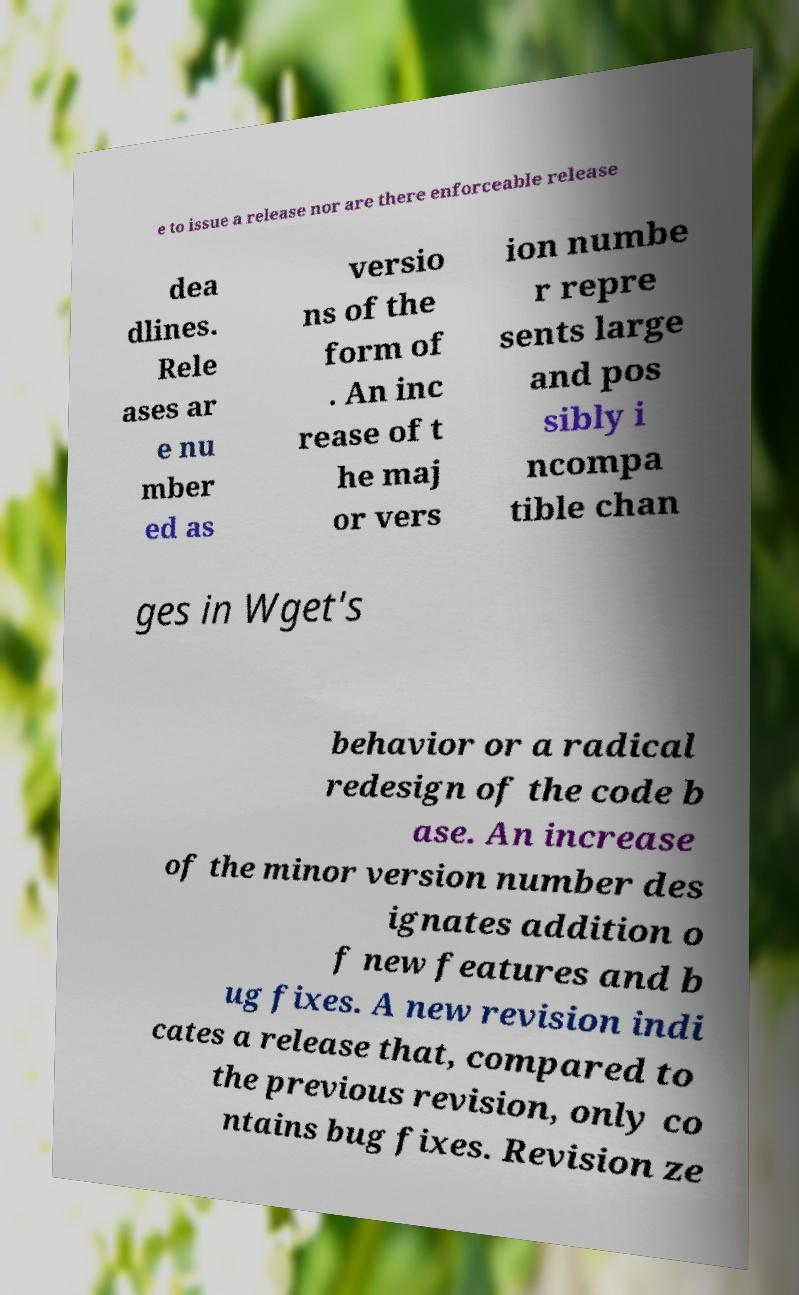I need the written content from this picture converted into text. Can you do that? e to issue a release nor are there enforceable release dea dlines. Rele ases ar e nu mber ed as versio ns of the form of . An inc rease of t he maj or vers ion numbe r repre sents large and pos sibly i ncompa tible chan ges in Wget's behavior or a radical redesign of the code b ase. An increase of the minor version number des ignates addition o f new features and b ug fixes. A new revision indi cates a release that, compared to the previous revision, only co ntains bug fixes. Revision ze 